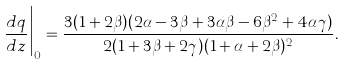<formula> <loc_0><loc_0><loc_500><loc_500>\frac { d q } { d z } \Big | _ { 0 } = \frac { 3 ( 1 + 2 \beta ) ( 2 \alpha - 3 \beta + 3 \alpha \beta - 6 \beta ^ { 2 } + 4 \alpha \gamma ) } { 2 ( 1 + 3 \beta + 2 \gamma ) ( 1 + \alpha + 2 \beta ) ^ { 2 } } .</formula> 